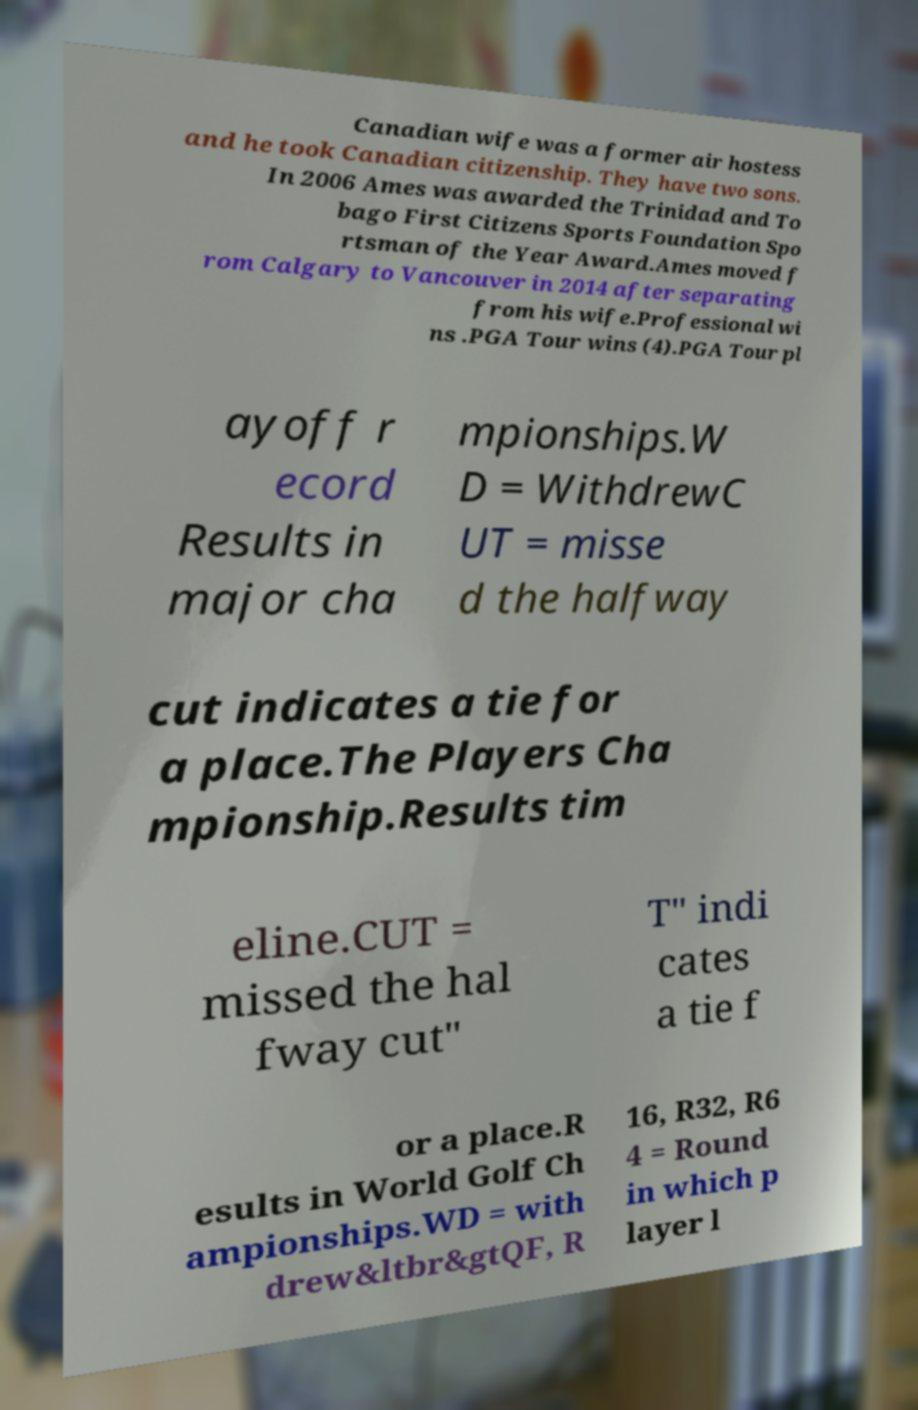Could you assist in decoding the text presented in this image and type it out clearly? Canadian wife was a former air hostess and he took Canadian citizenship. They have two sons. In 2006 Ames was awarded the Trinidad and To bago First Citizens Sports Foundation Spo rtsman of the Year Award.Ames moved f rom Calgary to Vancouver in 2014 after separating from his wife.Professional wi ns .PGA Tour wins (4).PGA Tour pl ayoff r ecord Results in major cha mpionships.W D = WithdrewC UT = misse d the halfway cut indicates a tie for a place.The Players Cha mpionship.Results tim eline.CUT = missed the hal fway cut" T" indi cates a tie f or a place.R esults in World Golf Ch ampionships.WD = with drew&ltbr&gtQF, R 16, R32, R6 4 = Round in which p layer l 